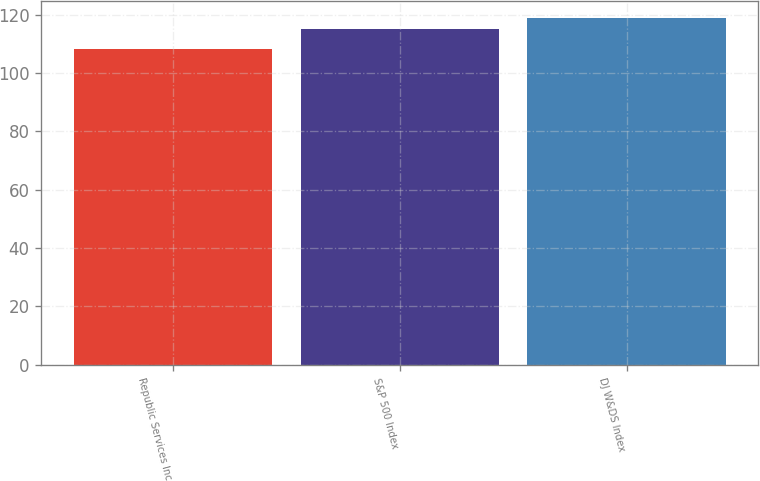<chart> <loc_0><loc_0><loc_500><loc_500><bar_chart><fcel>Republic Services Inc<fcel>S&P 500 Index<fcel>DJ W&DS Index<nl><fcel>108.27<fcel>115.06<fcel>118.78<nl></chart> 